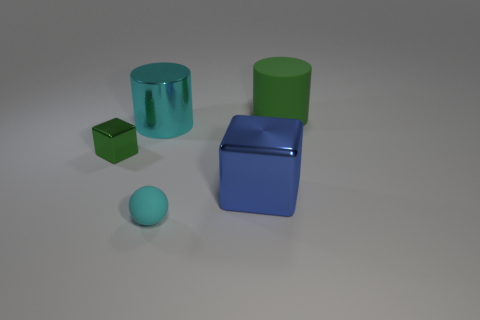Add 1 small green objects. How many objects exist? 6 Subtract all balls. How many objects are left? 4 Add 1 small cubes. How many small cubes exist? 2 Subtract 0 yellow spheres. How many objects are left? 5 Subtract all big cyan metallic cylinders. Subtract all small cyan rubber things. How many objects are left? 3 Add 1 big cyan cylinders. How many big cyan cylinders are left? 2 